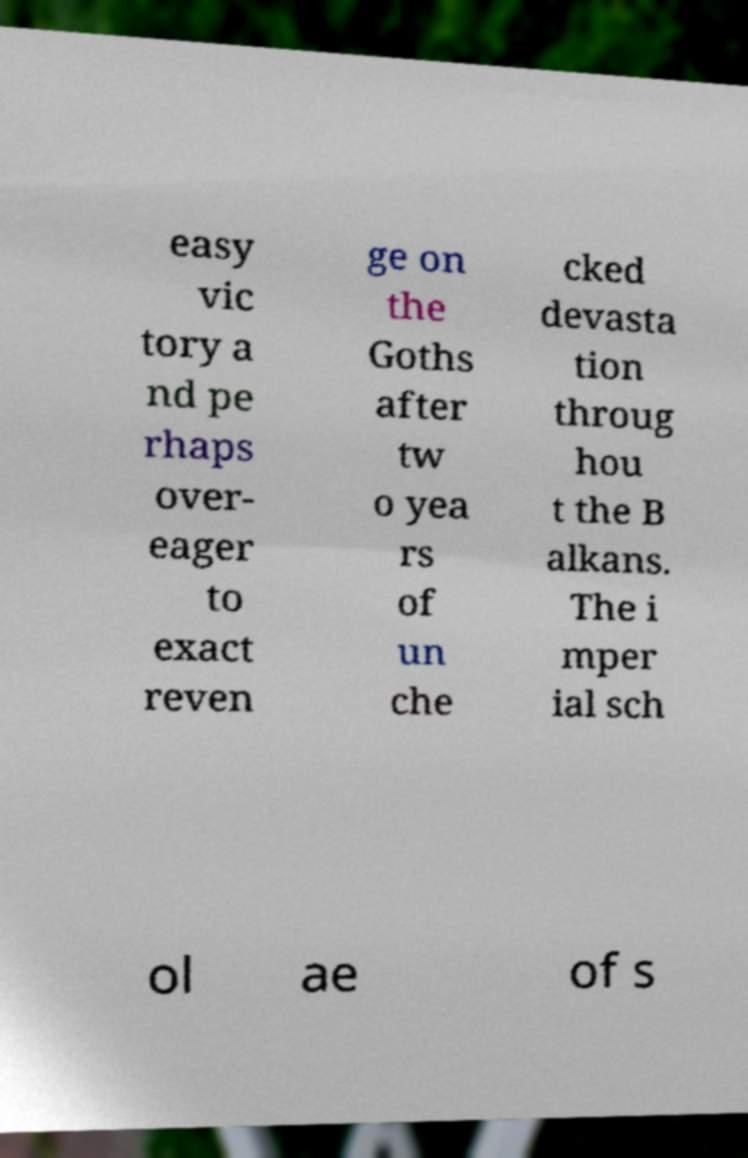Could you extract and type out the text from this image? easy vic tory a nd pe rhaps over- eager to exact reven ge on the Goths after tw o yea rs of un che cked devasta tion throug hou t the B alkans. The i mper ial sch ol ae of s 